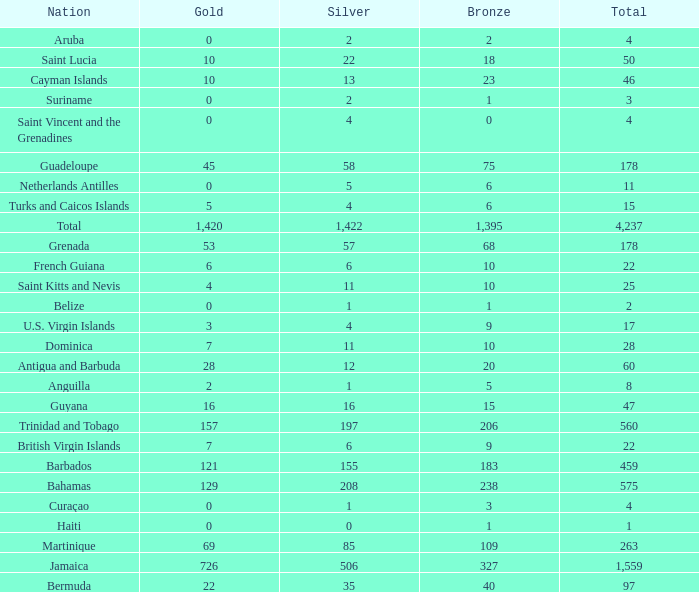What's the sum of Gold with a Bronze that's larger than 15, Silver that's smaller than 197, the Nation of Saint Lucia, and has a Total that is larger than 50? None. 